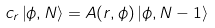Convert formula to latex. <formula><loc_0><loc_0><loc_500><loc_500>c _ { r } \left | \phi , N \right \rangle = A ( r , \phi ) \left | \phi , N - 1 \right \rangle</formula> 